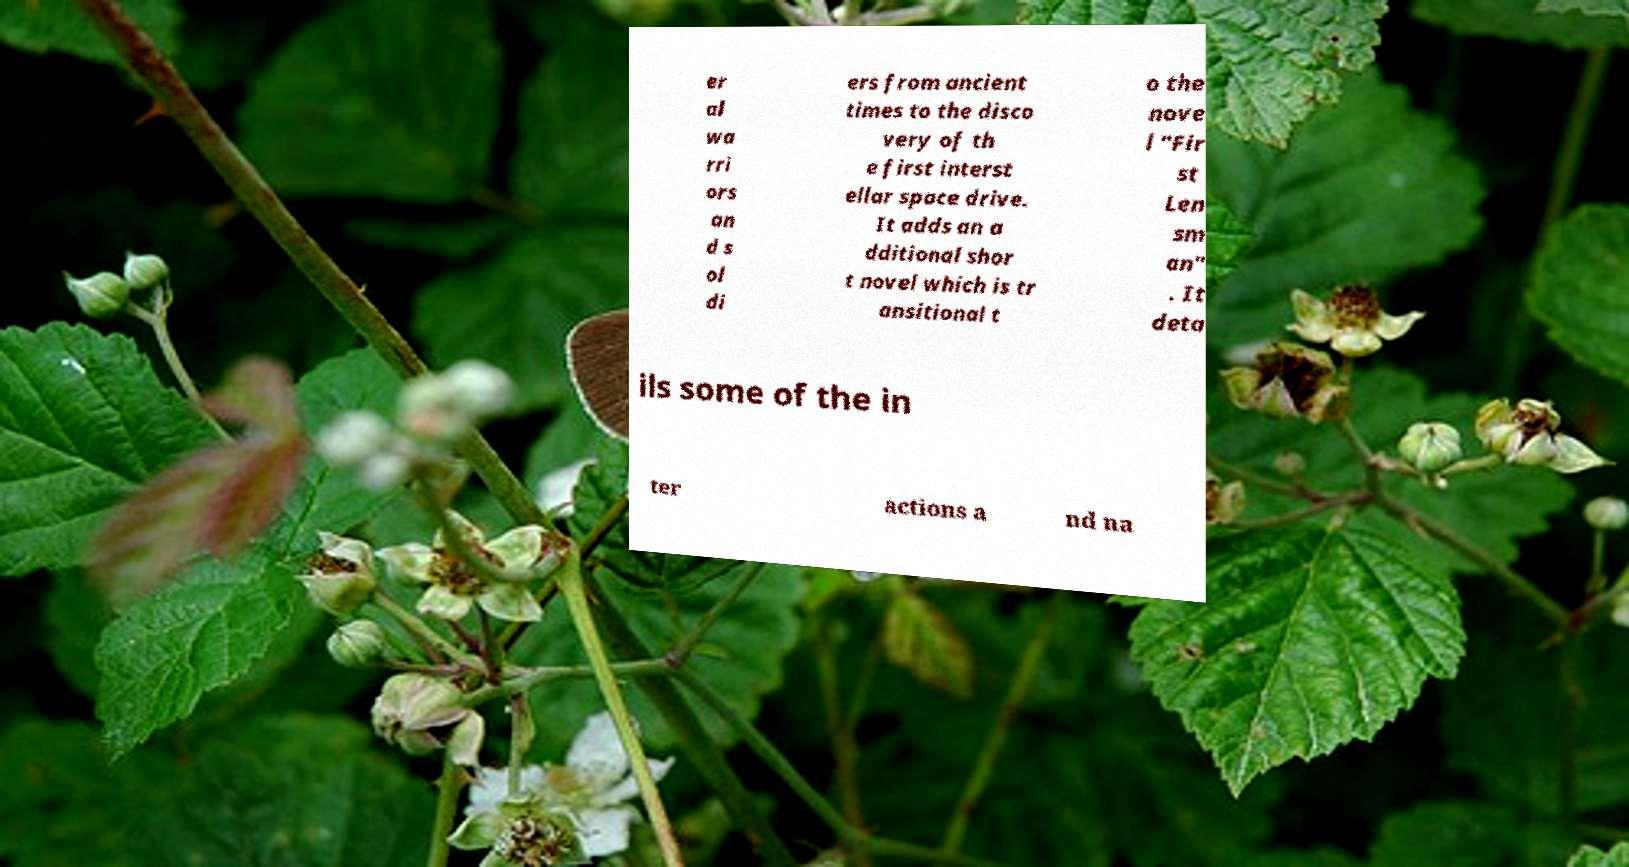For documentation purposes, I need the text within this image transcribed. Could you provide that? er al wa rri ors an d s ol di ers from ancient times to the disco very of th e first interst ellar space drive. It adds an a dditional shor t novel which is tr ansitional t o the nove l "Fir st Len sm an" . It deta ils some of the in ter actions a nd na 